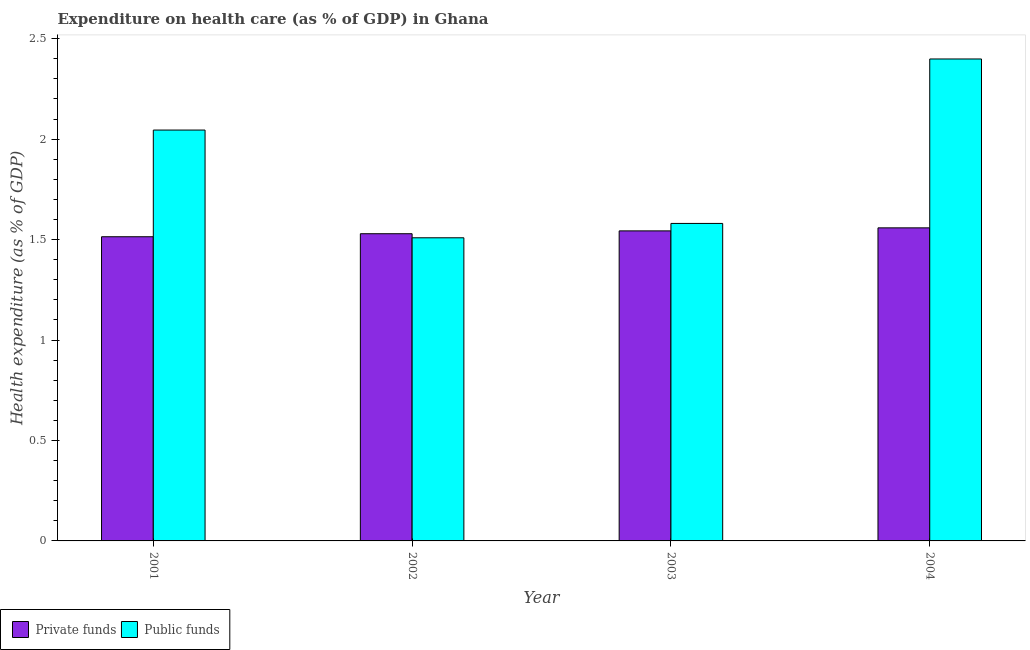Are the number of bars per tick equal to the number of legend labels?
Offer a terse response. Yes. How many bars are there on the 2nd tick from the left?
Offer a very short reply. 2. How many bars are there on the 1st tick from the right?
Ensure brevity in your answer.  2. What is the amount of private funds spent in healthcare in 2001?
Your response must be concise. 1.51. Across all years, what is the maximum amount of public funds spent in healthcare?
Offer a terse response. 2.4. Across all years, what is the minimum amount of public funds spent in healthcare?
Provide a succinct answer. 1.51. In which year was the amount of private funds spent in healthcare minimum?
Ensure brevity in your answer.  2001. What is the total amount of public funds spent in healthcare in the graph?
Your answer should be compact. 7.53. What is the difference between the amount of private funds spent in healthcare in 2001 and that in 2002?
Give a very brief answer. -0.02. What is the difference between the amount of private funds spent in healthcare in 2003 and the amount of public funds spent in healthcare in 2002?
Give a very brief answer. 0.01. What is the average amount of private funds spent in healthcare per year?
Your answer should be compact. 1.54. In the year 2004, what is the difference between the amount of public funds spent in healthcare and amount of private funds spent in healthcare?
Provide a short and direct response. 0. What is the ratio of the amount of public funds spent in healthcare in 2002 to that in 2004?
Give a very brief answer. 0.63. What is the difference between the highest and the second highest amount of private funds spent in healthcare?
Offer a terse response. 0.02. What is the difference between the highest and the lowest amount of private funds spent in healthcare?
Your response must be concise. 0.04. In how many years, is the amount of private funds spent in healthcare greater than the average amount of private funds spent in healthcare taken over all years?
Offer a very short reply. 2. What does the 1st bar from the left in 2002 represents?
Your answer should be very brief. Private funds. What does the 1st bar from the right in 2004 represents?
Keep it short and to the point. Public funds. How many bars are there?
Give a very brief answer. 8. Does the graph contain any zero values?
Offer a very short reply. No. Where does the legend appear in the graph?
Offer a terse response. Bottom left. How many legend labels are there?
Provide a succinct answer. 2. How are the legend labels stacked?
Offer a very short reply. Horizontal. What is the title of the graph?
Offer a terse response. Expenditure on health care (as % of GDP) in Ghana. Does "Males" appear as one of the legend labels in the graph?
Provide a succinct answer. No. What is the label or title of the X-axis?
Make the answer very short. Year. What is the label or title of the Y-axis?
Keep it short and to the point. Health expenditure (as % of GDP). What is the Health expenditure (as % of GDP) of Private funds in 2001?
Your answer should be very brief. 1.51. What is the Health expenditure (as % of GDP) of Public funds in 2001?
Give a very brief answer. 2.05. What is the Health expenditure (as % of GDP) of Private funds in 2002?
Your answer should be compact. 1.53. What is the Health expenditure (as % of GDP) of Public funds in 2002?
Your response must be concise. 1.51. What is the Health expenditure (as % of GDP) in Private funds in 2003?
Offer a very short reply. 1.54. What is the Health expenditure (as % of GDP) of Public funds in 2003?
Give a very brief answer. 1.58. What is the Health expenditure (as % of GDP) of Private funds in 2004?
Give a very brief answer. 1.56. What is the Health expenditure (as % of GDP) in Public funds in 2004?
Keep it short and to the point. 2.4. Across all years, what is the maximum Health expenditure (as % of GDP) in Private funds?
Give a very brief answer. 1.56. Across all years, what is the maximum Health expenditure (as % of GDP) of Public funds?
Make the answer very short. 2.4. Across all years, what is the minimum Health expenditure (as % of GDP) in Private funds?
Your answer should be very brief. 1.51. Across all years, what is the minimum Health expenditure (as % of GDP) in Public funds?
Your answer should be compact. 1.51. What is the total Health expenditure (as % of GDP) in Private funds in the graph?
Ensure brevity in your answer.  6.15. What is the total Health expenditure (as % of GDP) of Public funds in the graph?
Give a very brief answer. 7.53. What is the difference between the Health expenditure (as % of GDP) in Private funds in 2001 and that in 2002?
Your answer should be very brief. -0.01. What is the difference between the Health expenditure (as % of GDP) of Public funds in 2001 and that in 2002?
Make the answer very short. 0.54. What is the difference between the Health expenditure (as % of GDP) of Private funds in 2001 and that in 2003?
Ensure brevity in your answer.  -0.03. What is the difference between the Health expenditure (as % of GDP) of Public funds in 2001 and that in 2003?
Provide a succinct answer. 0.46. What is the difference between the Health expenditure (as % of GDP) in Private funds in 2001 and that in 2004?
Provide a succinct answer. -0.04. What is the difference between the Health expenditure (as % of GDP) of Public funds in 2001 and that in 2004?
Offer a very short reply. -0.35. What is the difference between the Health expenditure (as % of GDP) of Private funds in 2002 and that in 2003?
Offer a very short reply. -0.01. What is the difference between the Health expenditure (as % of GDP) in Public funds in 2002 and that in 2003?
Give a very brief answer. -0.07. What is the difference between the Health expenditure (as % of GDP) in Private funds in 2002 and that in 2004?
Ensure brevity in your answer.  -0.03. What is the difference between the Health expenditure (as % of GDP) of Public funds in 2002 and that in 2004?
Give a very brief answer. -0.89. What is the difference between the Health expenditure (as % of GDP) in Private funds in 2003 and that in 2004?
Provide a short and direct response. -0.02. What is the difference between the Health expenditure (as % of GDP) in Public funds in 2003 and that in 2004?
Your answer should be very brief. -0.82. What is the difference between the Health expenditure (as % of GDP) of Private funds in 2001 and the Health expenditure (as % of GDP) of Public funds in 2002?
Give a very brief answer. 0.01. What is the difference between the Health expenditure (as % of GDP) of Private funds in 2001 and the Health expenditure (as % of GDP) of Public funds in 2003?
Your answer should be compact. -0.07. What is the difference between the Health expenditure (as % of GDP) in Private funds in 2001 and the Health expenditure (as % of GDP) in Public funds in 2004?
Your response must be concise. -0.89. What is the difference between the Health expenditure (as % of GDP) of Private funds in 2002 and the Health expenditure (as % of GDP) of Public funds in 2003?
Provide a short and direct response. -0.05. What is the difference between the Health expenditure (as % of GDP) in Private funds in 2002 and the Health expenditure (as % of GDP) in Public funds in 2004?
Offer a very short reply. -0.87. What is the difference between the Health expenditure (as % of GDP) of Private funds in 2003 and the Health expenditure (as % of GDP) of Public funds in 2004?
Offer a very short reply. -0.86. What is the average Health expenditure (as % of GDP) of Private funds per year?
Your answer should be very brief. 1.54. What is the average Health expenditure (as % of GDP) in Public funds per year?
Offer a very short reply. 1.88. In the year 2001, what is the difference between the Health expenditure (as % of GDP) in Private funds and Health expenditure (as % of GDP) in Public funds?
Make the answer very short. -0.53. In the year 2002, what is the difference between the Health expenditure (as % of GDP) of Private funds and Health expenditure (as % of GDP) of Public funds?
Give a very brief answer. 0.02. In the year 2003, what is the difference between the Health expenditure (as % of GDP) of Private funds and Health expenditure (as % of GDP) of Public funds?
Provide a succinct answer. -0.04. In the year 2004, what is the difference between the Health expenditure (as % of GDP) of Private funds and Health expenditure (as % of GDP) of Public funds?
Offer a terse response. -0.84. What is the ratio of the Health expenditure (as % of GDP) of Private funds in 2001 to that in 2002?
Your answer should be very brief. 0.99. What is the ratio of the Health expenditure (as % of GDP) in Public funds in 2001 to that in 2002?
Your response must be concise. 1.36. What is the ratio of the Health expenditure (as % of GDP) in Private funds in 2001 to that in 2003?
Give a very brief answer. 0.98. What is the ratio of the Health expenditure (as % of GDP) of Public funds in 2001 to that in 2003?
Provide a succinct answer. 1.29. What is the ratio of the Health expenditure (as % of GDP) in Private funds in 2001 to that in 2004?
Give a very brief answer. 0.97. What is the ratio of the Health expenditure (as % of GDP) of Public funds in 2001 to that in 2004?
Your response must be concise. 0.85. What is the ratio of the Health expenditure (as % of GDP) in Private funds in 2002 to that in 2003?
Provide a succinct answer. 0.99. What is the ratio of the Health expenditure (as % of GDP) of Public funds in 2002 to that in 2003?
Keep it short and to the point. 0.95. What is the ratio of the Health expenditure (as % of GDP) in Private funds in 2002 to that in 2004?
Give a very brief answer. 0.98. What is the ratio of the Health expenditure (as % of GDP) of Public funds in 2002 to that in 2004?
Your answer should be compact. 0.63. What is the ratio of the Health expenditure (as % of GDP) in Private funds in 2003 to that in 2004?
Your answer should be very brief. 0.99. What is the ratio of the Health expenditure (as % of GDP) in Public funds in 2003 to that in 2004?
Your response must be concise. 0.66. What is the difference between the highest and the second highest Health expenditure (as % of GDP) of Private funds?
Your answer should be very brief. 0.02. What is the difference between the highest and the second highest Health expenditure (as % of GDP) in Public funds?
Your answer should be very brief. 0.35. What is the difference between the highest and the lowest Health expenditure (as % of GDP) in Private funds?
Your answer should be very brief. 0.04. What is the difference between the highest and the lowest Health expenditure (as % of GDP) in Public funds?
Provide a succinct answer. 0.89. 